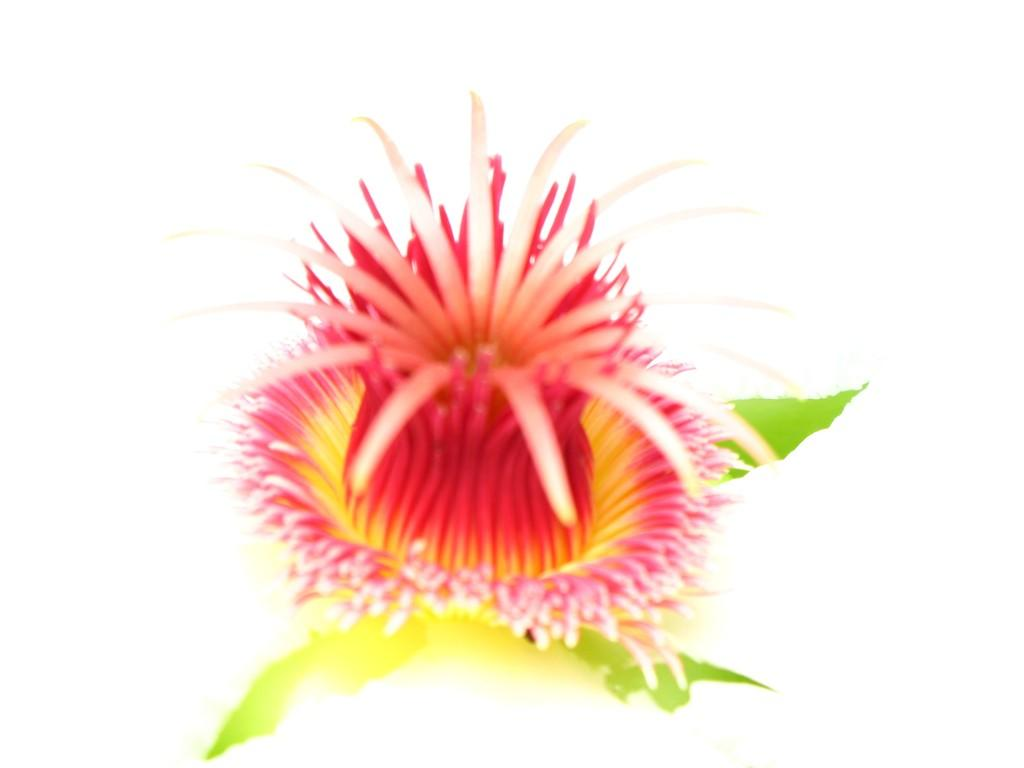What is the main subject of the image? There is a flower in the image. What is the color of the surface the flower is on? The flower is on a white surface. What is the name of the train passing by in the image? There is no train present in the image; it only features a flower on a white surface. 